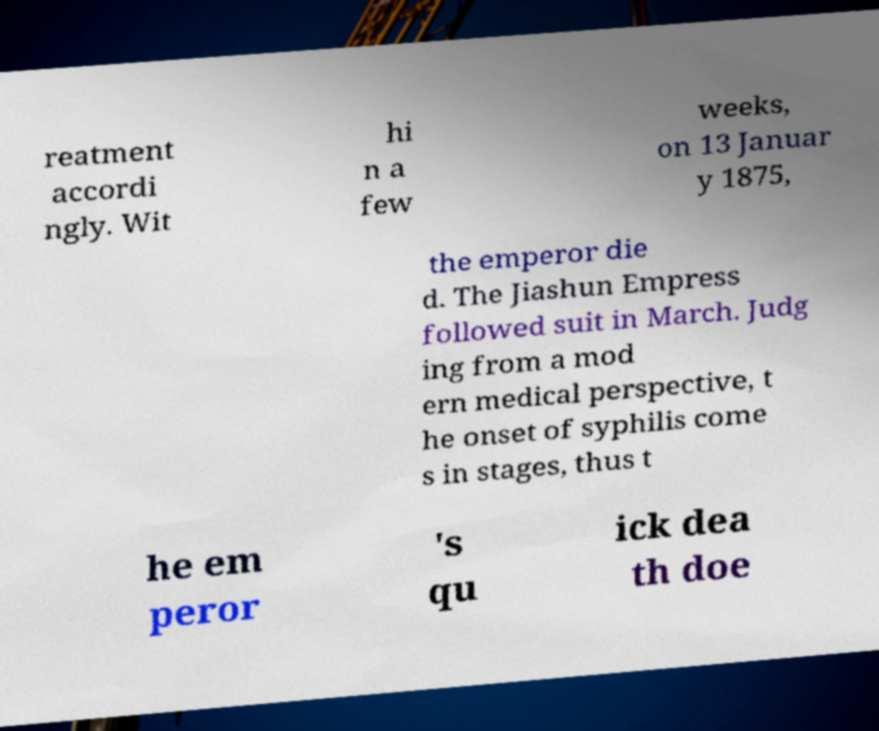I need the written content from this picture converted into text. Can you do that? reatment accordi ngly. Wit hi n a few weeks, on 13 Januar y 1875, the emperor die d. The Jiashun Empress followed suit in March. Judg ing from a mod ern medical perspective, t he onset of syphilis come s in stages, thus t he em peror 's qu ick dea th doe 